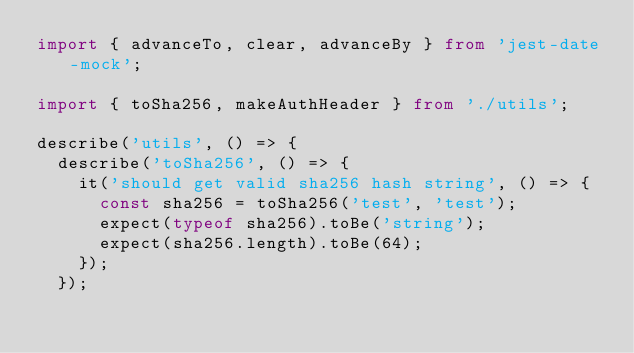Convert code to text. <code><loc_0><loc_0><loc_500><loc_500><_TypeScript_>import { advanceTo, clear, advanceBy } from 'jest-date-mock';

import { toSha256, makeAuthHeader } from './utils';

describe('utils', () => {
  describe('toSha256', () => {
    it('should get valid sha256 hash string', () => {
      const sha256 = toSha256('test', 'test');
      expect(typeof sha256).toBe('string');
      expect(sha256.length).toBe(64);
    });
  });
</code> 